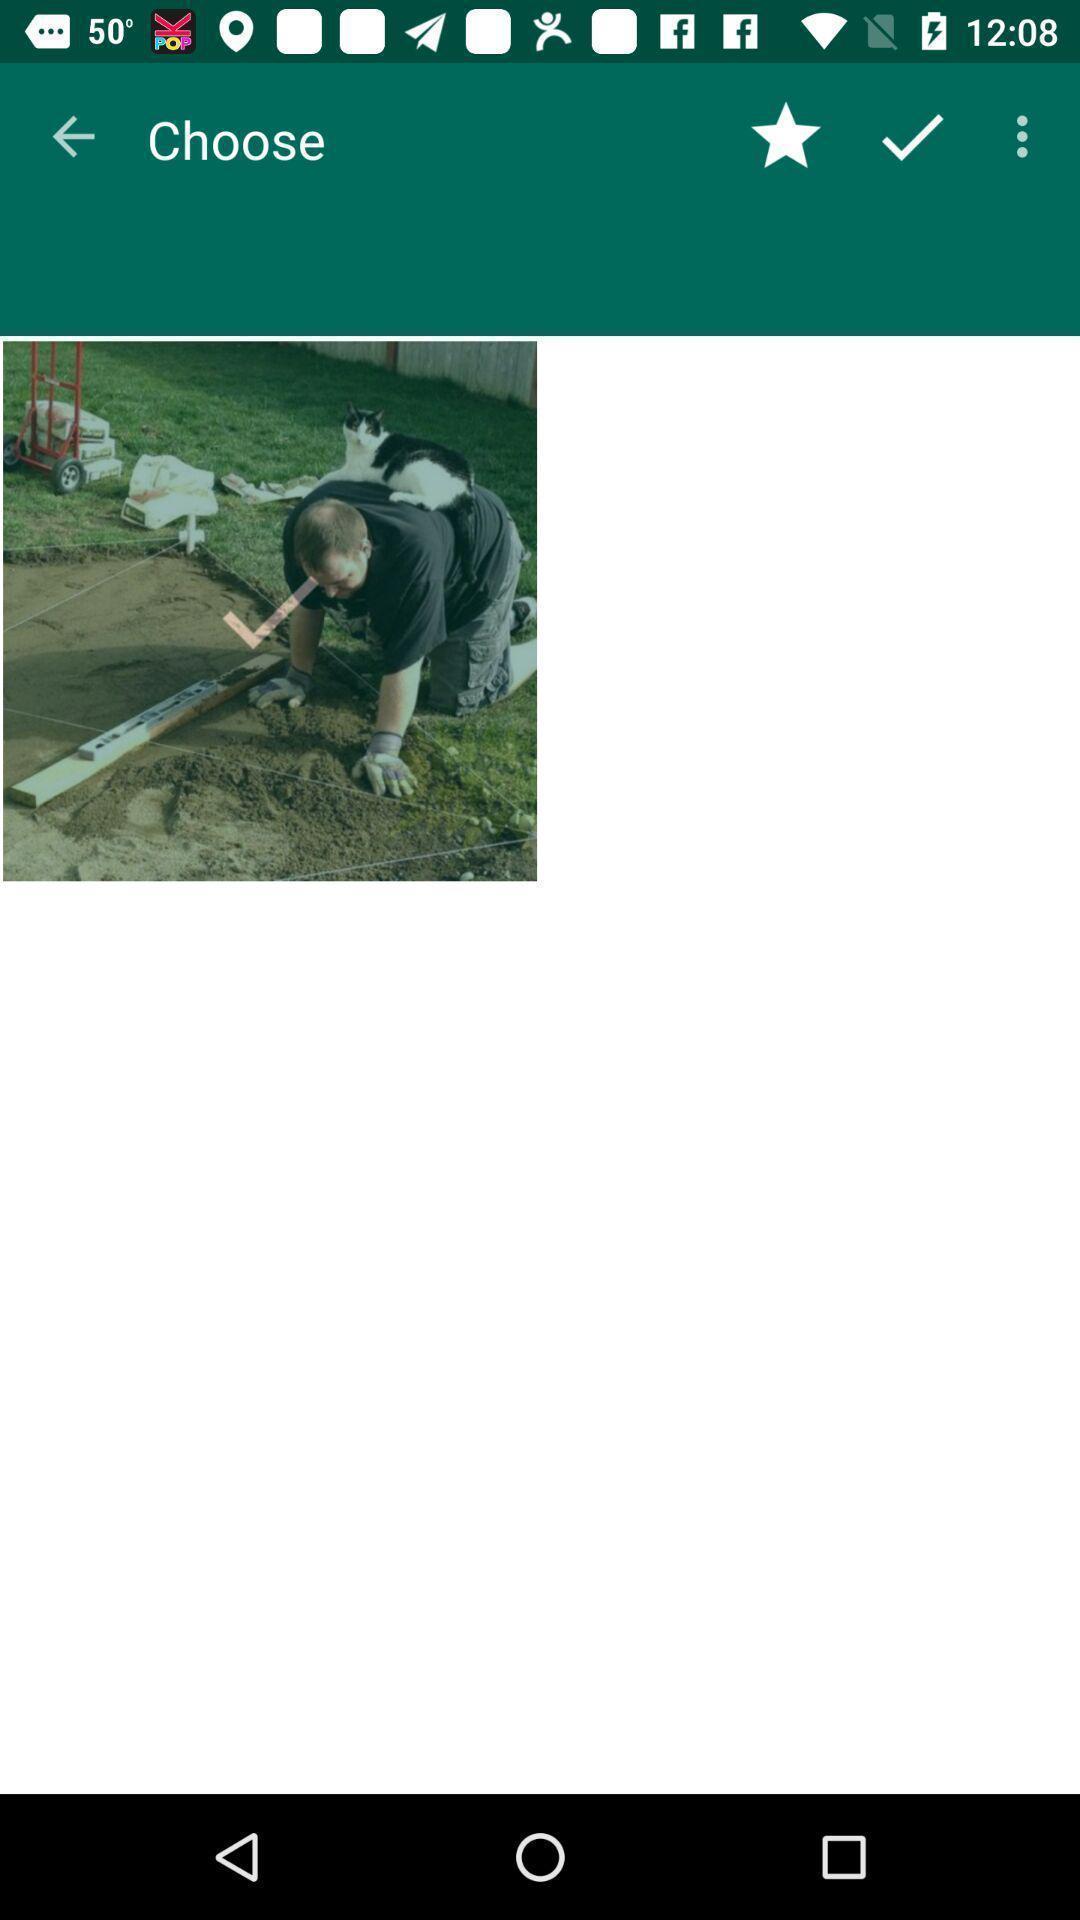Tell me about the visual elements in this screen capture. Screen showing choose image. 